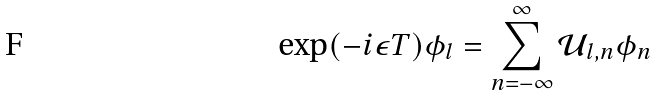<formula> <loc_0><loc_0><loc_500><loc_500>\exp ( - i \epsilon T ) \phi _ { l } = \sum _ { n = - \infty } ^ { \infty } \mathcal { U } _ { l , n } \phi _ { n }</formula> 